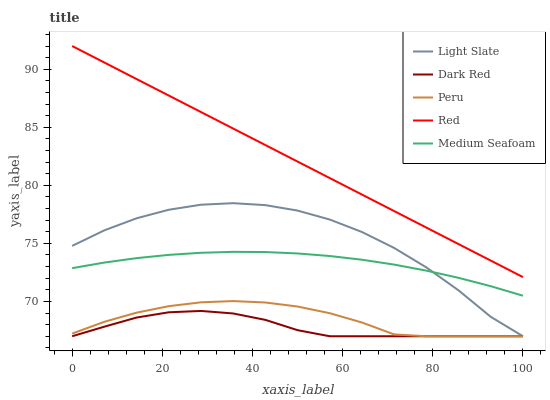Does Dark Red have the minimum area under the curve?
Answer yes or no. Yes. Does Red have the maximum area under the curve?
Answer yes or no. Yes. Does Red have the minimum area under the curve?
Answer yes or no. No. Does Dark Red have the maximum area under the curve?
Answer yes or no. No. Is Red the smoothest?
Answer yes or no. Yes. Is Light Slate the roughest?
Answer yes or no. Yes. Is Dark Red the smoothest?
Answer yes or no. No. Is Dark Red the roughest?
Answer yes or no. No. Does Light Slate have the lowest value?
Answer yes or no. Yes. Does Red have the lowest value?
Answer yes or no. No. Does Red have the highest value?
Answer yes or no. Yes. Does Dark Red have the highest value?
Answer yes or no. No. Is Dark Red less than Medium Seafoam?
Answer yes or no. Yes. Is Red greater than Medium Seafoam?
Answer yes or no. Yes. Does Medium Seafoam intersect Light Slate?
Answer yes or no. Yes. Is Medium Seafoam less than Light Slate?
Answer yes or no. No. Is Medium Seafoam greater than Light Slate?
Answer yes or no. No. Does Dark Red intersect Medium Seafoam?
Answer yes or no. No. 